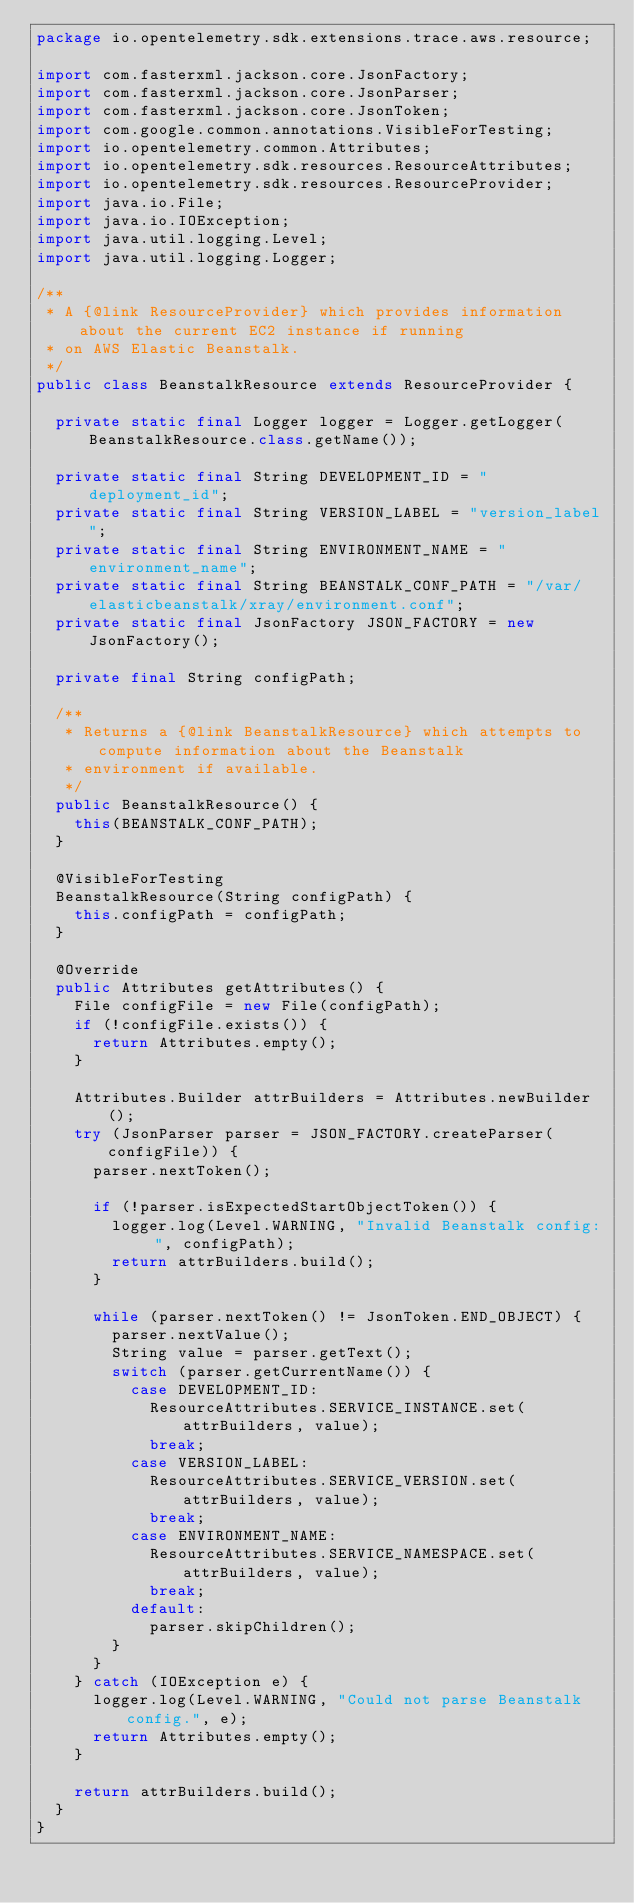Convert code to text. <code><loc_0><loc_0><loc_500><loc_500><_Java_>package io.opentelemetry.sdk.extensions.trace.aws.resource;

import com.fasterxml.jackson.core.JsonFactory;
import com.fasterxml.jackson.core.JsonParser;
import com.fasterxml.jackson.core.JsonToken;
import com.google.common.annotations.VisibleForTesting;
import io.opentelemetry.common.Attributes;
import io.opentelemetry.sdk.resources.ResourceAttributes;
import io.opentelemetry.sdk.resources.ResourceProvider;
import java.io.File;
import java.io.IOException;
import java.util.logging.Level;
import java.util.logging.Logger;

/**
 * A {@link ResourceProvider} which provides information about the current EC2 instance if running
 * on AWS Elastic Beanstalk.
 */
public class BeanstalkResource extends ResourceProvider {

  private static final Logger logger = Logger.getLogger(BeanstalkResource.class.getName());

  private static final String DEVELOPMENT_ID = "deployment_id";
  private static final String VERSION_LABEL = "version_label";
  private static final String ENVIRONMENT_NAME = "environment_name";
  private static final String BEANSTALK_CONF_PATH = "/var/elasticbeanstalk/xray/environment.conf";
  private static final JsonFactory JSON_FACTORY = new JsonFactory();

  private final String configPath;

  /**
   * Returns a {@link BeanstalkResource} which attempts to compute information about the Beanstalk
   * environment if available.
   */
  public BeanstalkResource() {
    this(BEANSTALK_CONF_PATH);
  }

  @VisibleForTesting
  BeanstalkResource(String configPath) {
    this.configPath = configPath;
  }

  @Override
  public Attributes getAttributes() {
    File configFile = new File(configPath);
    if (!configFile.exists()) {
      return Attributes.empty();
    }

    Attributes.Builder attrBuilders = Attributes.newBuilder();
    try (JsonParser parser = JSON_FACTORY.createParser(configFile)) {
      parser.nextToken();

      if (!parser.isExpectedStartObjectToken()) {
        logger.log(Level.WARNING, "Invalid Beanstalk config: ", configPath);
        return attrBuilders.build();
      }

      while (parser.nextToken() != JsonToken.END_OBJECT) {
        parser.nextValue();
        String value = parser.getText();
        switch (parser.getCurrentName()) {
          case DEVELOPMENT_ID:
            ResourceAttributes.SERVICE_INSTANCE.set(attrBuilders, value);
            break;
          case VERSION_LABEL:
            ResourceAttributes.SERVICE_VERSION.set(attrBuilders, value);
            break;
          case ENVIRONMENT_NAME:
            ResourceAttributes.SERVICE_NAMESPACE.set(attrBuilders, value);
            break;
          default:
            parser.skipChildren();
        }
      }
    } catch (IOException e) {
      logger.log(Level.WARNING, "Could not parse Beanstalk config.", e);
      return Attributes.empty();
    }

    return attrBuilders.build();
  }
}
</code> 